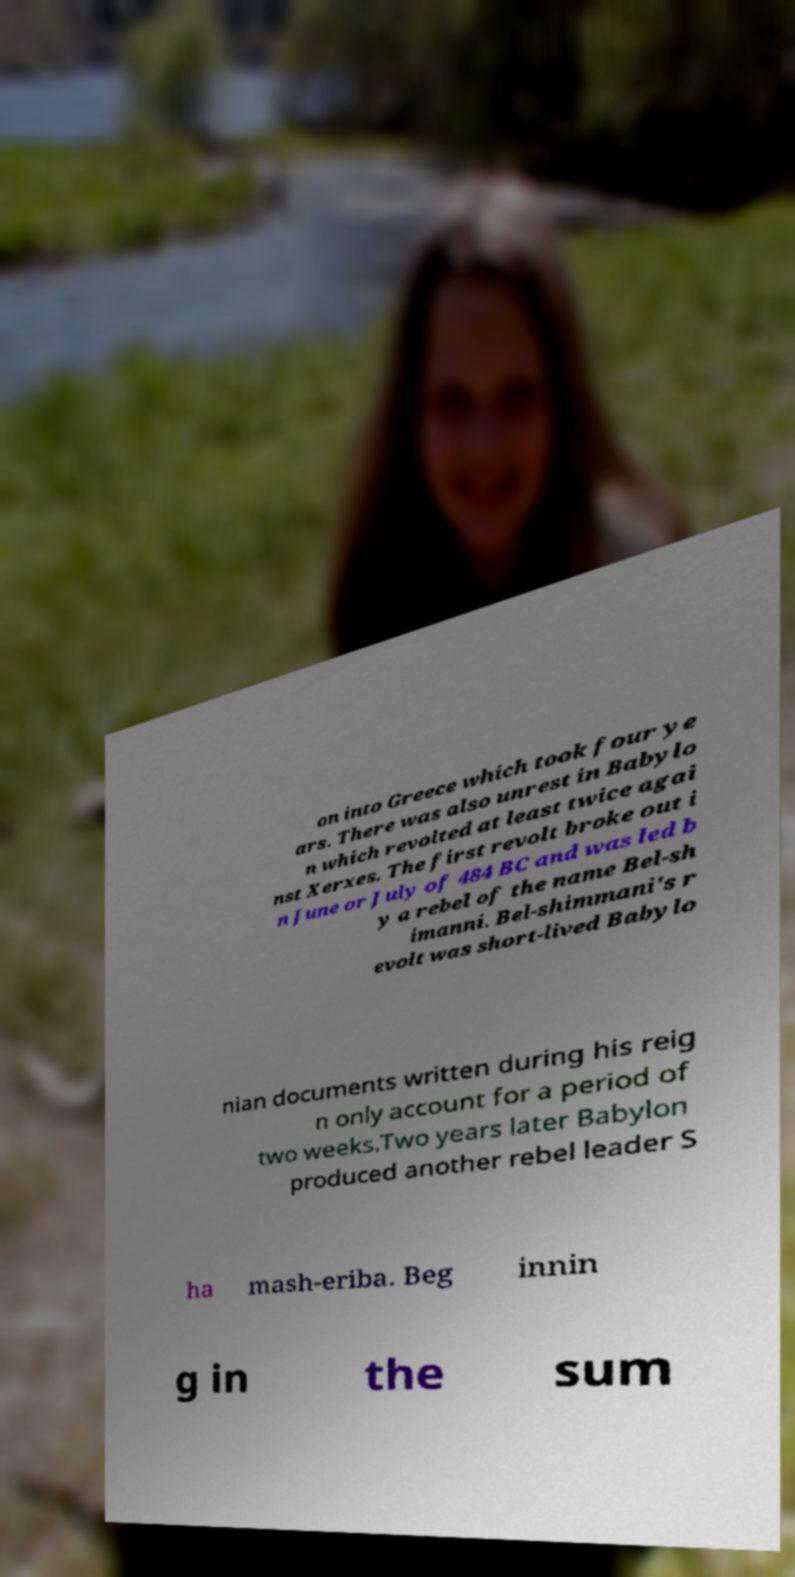For documentation purposes, I need the text within this image transcribed. Could you provide that? on into Greece which took four ye ars. There was also unrest in Babylo n which revolted at least twice agai nst Xerxes. The first revolt broke out i n June or July of 484 BC and was led b y a rebel of the name Bel-sh imanni. Bel-shimmani's r evolt was short-lived Babylo nian documents written during his reig n only account for a period of two weeks.Two years later Babylon produced another rebel leader S ha mash-eriba. Beg innin g in the sum 